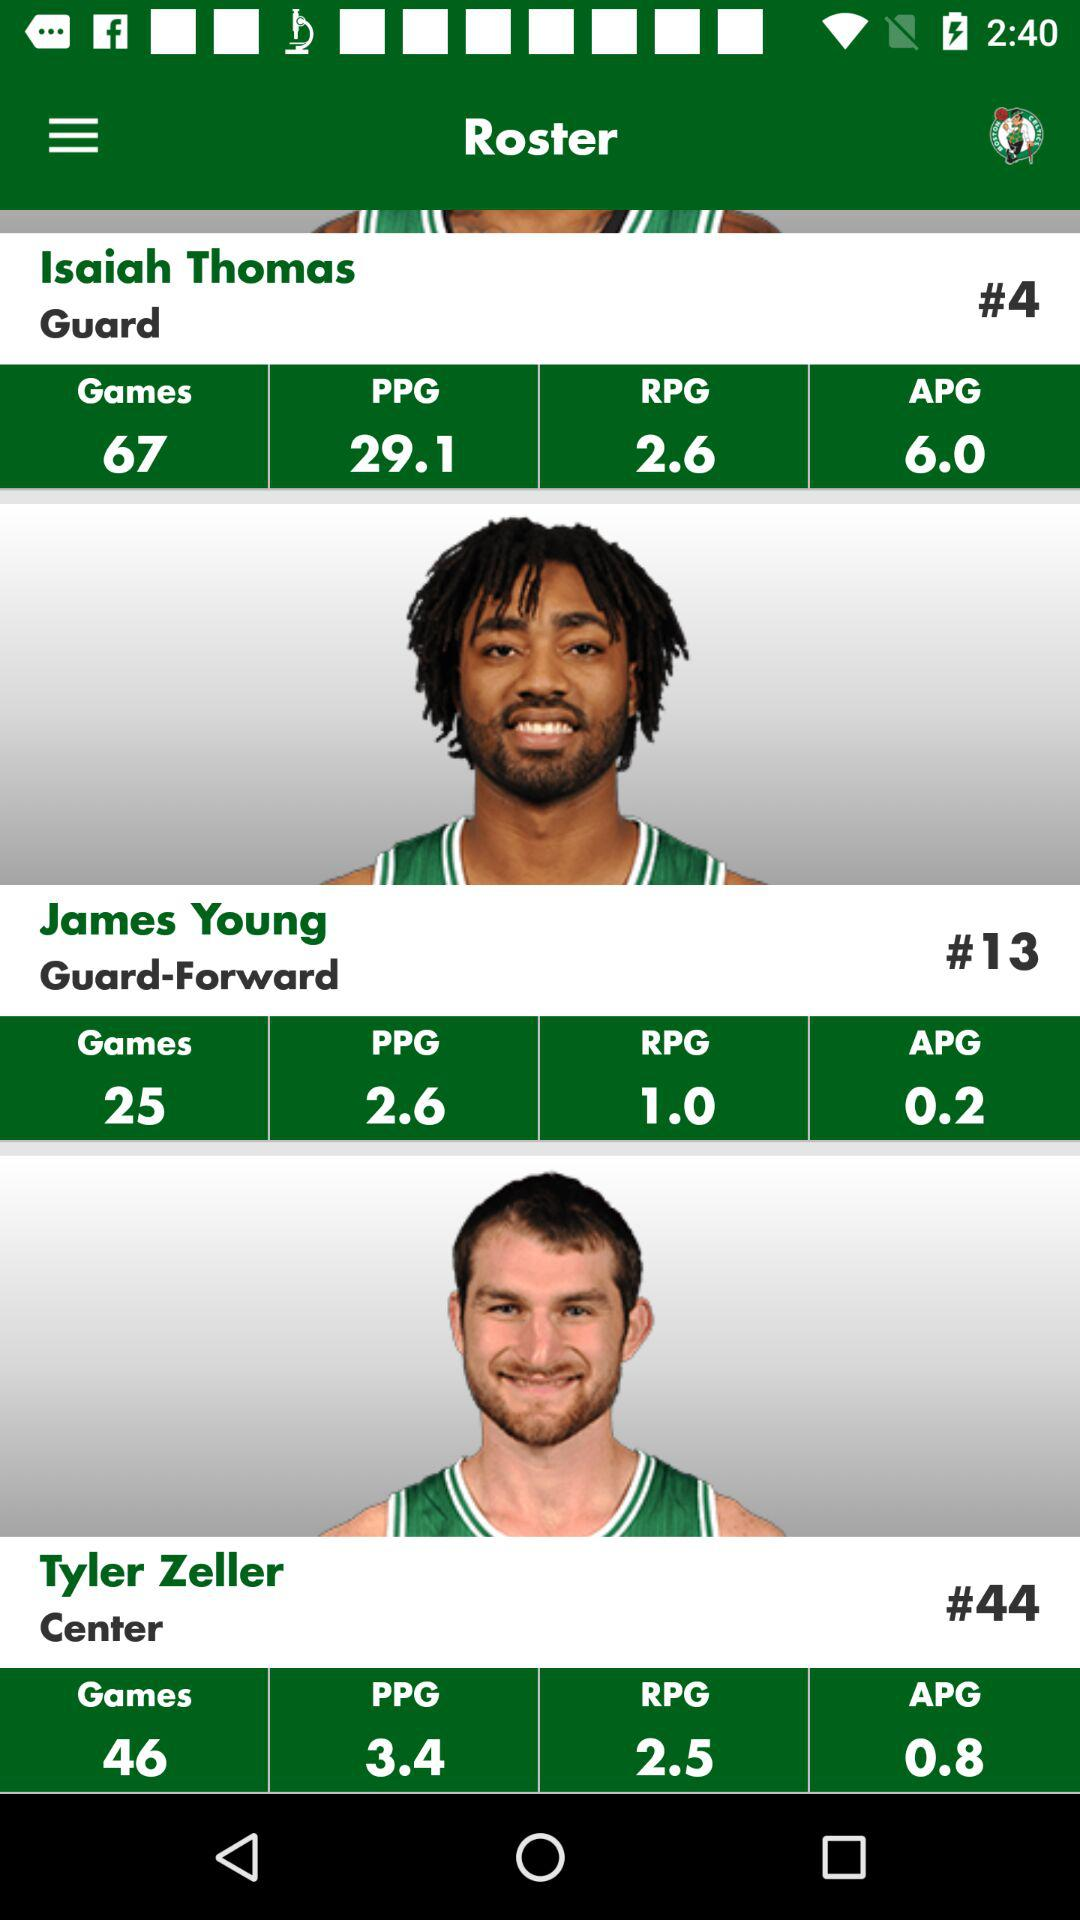What is the APG point for James Young? The APG point for James Young is 0.2. 